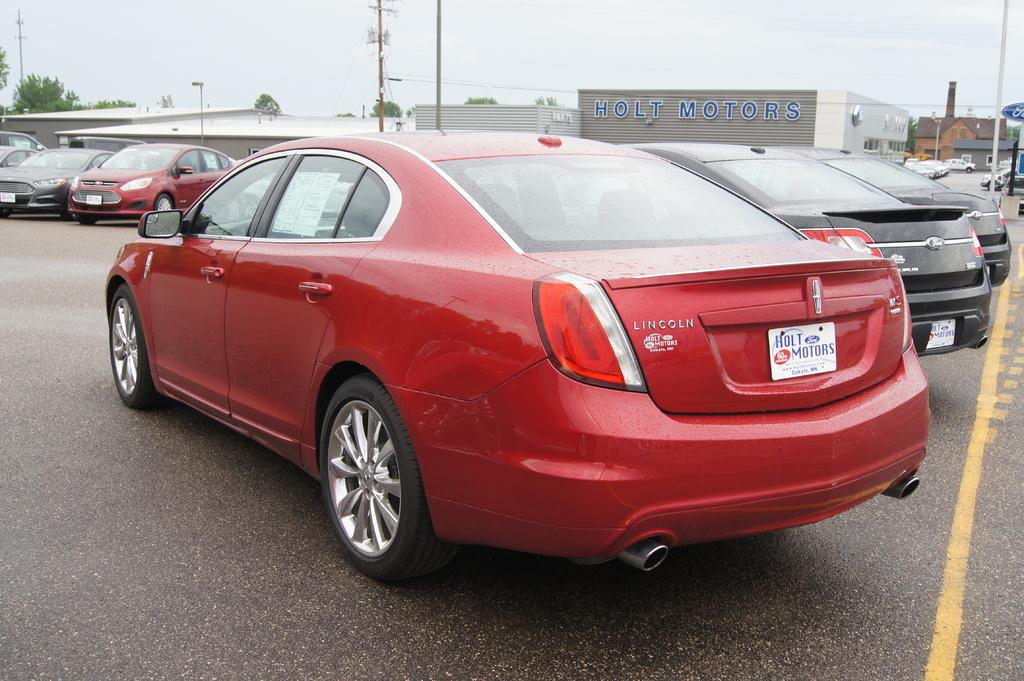What can be seen on the road in the image? There are vehicles on the road in the image. What is visible in the background of the image? There are buildings, trees, poles, and other objects in the background of the image. What part of the natural environment is visible in the image? The sky is visible in the image. How many hours of sleep does the achiever get in the image? There is no achiever or mention of sleep in the image. What type of wound can be seen on the person in the image? There is no person or wound present in the image. 